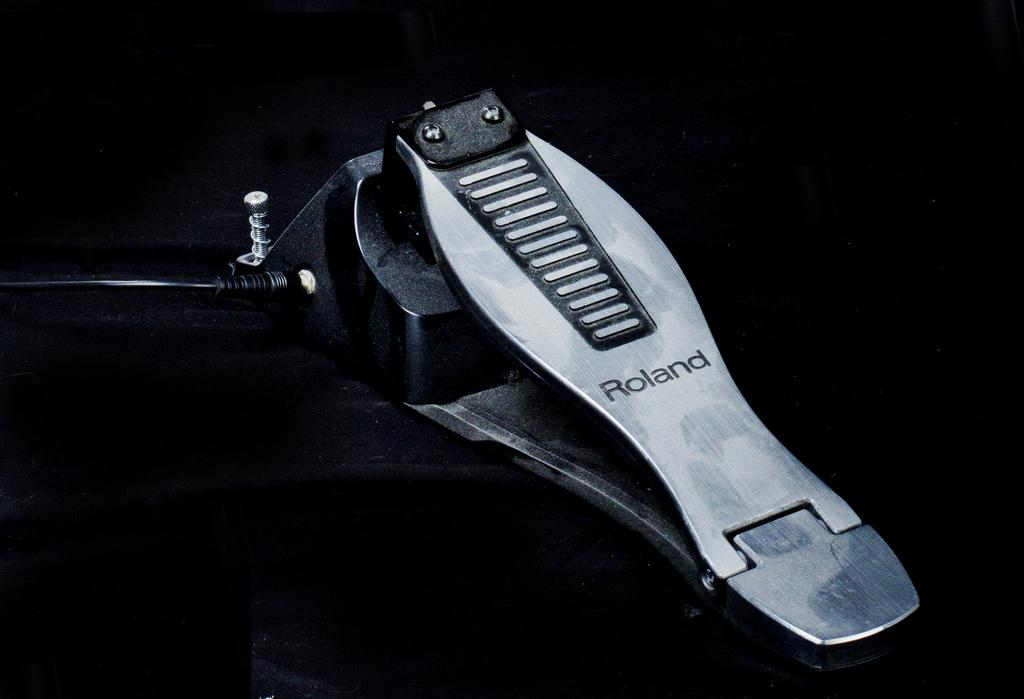What can be seen in the image? There is an object in the image. What colors are present in the object? The object is in black and ash color. What is the color of the background in the image? The background of the image is black. How does the object grip the surface during its journey in the image? There is no journey or gripping action present in the image; it simply shows an object with a black and ash color against a black background. 